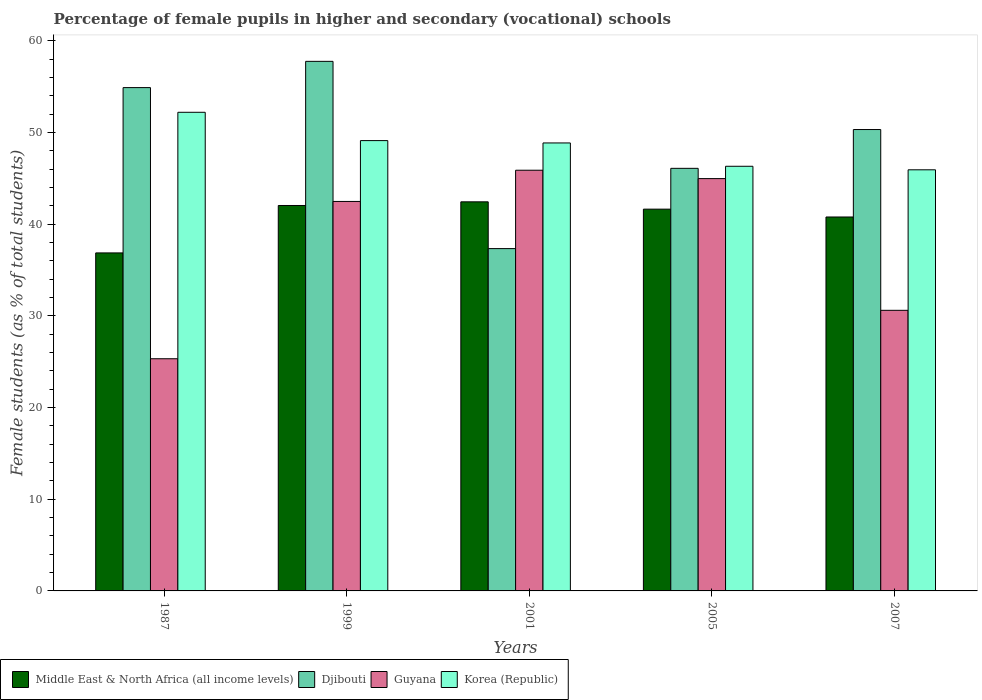How many different coloured bars are there?
Your answer should be very brief. 4. How many groups of bars are there?
Give a very brief answer. 5. How many bars are there on the 3rd tick from the left?
Your response must be concise. 4. How many bars are there on the 3rd tick from the right?
Offer a very short reply. 4. What is the percentage of female pupils in higher and secondary schools in Guyana in 1999?
Your answer should be compact. 42.49. Across all years, what is the maximum percentage of female pupils in higher and secondary schools in Middle East & North Africa (all income levels)?
Your answer should be compact. 42.45. Across all years, what is the minimum percentage of female pupils in higher and secondary schools in Djibouti?
Give a very brief answer. 37.34. In which year was the percentage of female pupils in higher and secondary schools in Middle East & North Africa (all income levels) maximum?
Provide a succinct answer. 2001. What is the total percentage of female pupils in higher and secondary schools in Middle East & North Africa (all income levels) in the graph?
Give a very brief answer. 203.8. What is the difference between the percentage of female pupils in higher and secondary schools in Djibouti in 2001 and that in 2007?
Offer a terse response. -12.99. What is the difference between the percentage of female pupils in higher and secondary schools in Djibouti in 2007 and the percentage of female pupils in higher and secondary schools in Guyana in 2001?
Keep it short and to the point. 4.44. What is the average percentage of female pupils in higher and secondary schools in Korea (Republic) per year?
Ensure brevity in your answer.  48.49. In the year 2007, what is the difference between the percentage of female pupils in higher and secondary schools in Korea (Republic) and percentage of female pupils in higher and secondary schools in Middle East & North Africa (all income levels)?
Provide a short and direct response. 5.15. What is the ratio of the percentage of female pupils in higher and secondary schools in Djibouti in 1999 to that in 2001?
Give a very brief answer. 1.55. Is the percentage of female pupils in higher and secondary schools in Guyana in 1999 less than that in 2007?
Provide a succinct answer. No. Is the difference between the percentage of female pupils in higher and secondary schools in Korea (Republic) in 1987 and 2005 greater than the difference between the percentage of female pupils in higher and secondary schools in Middle East & North Africa (all income levels) in 1987 and 2005?
Make the answer very short. Yes. What is the difference between the highest and the second highest percentage of female pupils in higher and secondary schools in Korea (Republic)?
Your answer should be very brief. 3.09. What is the difference between the highest and the lowest percentage of female pupils in higher and secondary schools in Middle East & North Africa (all income levels)?
Your answer should be compact. 5.57. In how many years, is the percentage of female pupils in higher and secondary schools in Middle East & North Africa (all income levels) greater than the average percentage of female pupils in higher and secondary schools in Middle East & North Africa (all income levels) taken over all years?
Ensure brevity in your answer.  4. What does the 1st bar from the left in 2001 represents?
Ensure brevity in your answer.  Middle East & North Africa (all income levels). What does the 2nd bar from the right in 2001 represents?
Make the answer very short. Guyana. Is it the case that in every year, the sum of the percentage of female pupils in higher and secondary schools in Guyana and percentage of female pupils in higher and secondary schools in Djibouti is greater than the percentage of female pupils in higher and secondary schools in Korea (Republic)?
Offer a very short reply. Yes. Are all the bars in the graph horizontal?
Keep it short and to the point. No. How many years are there in the graph?
Offer a very short reply. 5. Does the graph contain grids?
Give a very brief answer. No. How are the legend labels stacked?
Make the answer very short. Horizontal. What is the title of the graph?
Offer a very short reply. Percentage of female pupils in higher and secondary (vocational) schools. What is the label or title of the X-axis?
Offer a terse response. Years. What is the label or title of the Y-axis?
Offer a terse response. Female students (as % of total students). What is the Female students (as % of total students) of Middle East & North Africa (all income levels) in 1987?
Provide a succinct answer. 36.87. What is the Female students (as % of total students) in Djibouti in 1987?
Offer a very short reply. 54.91. What is the Female students (as % of total students) of Guyana in 1987?
Offer a very short reply. 25.33. What is the Female students (as % of total students) of Korea (Republic) in 1987?
Your answer should be very brief. 52.21. What is the Female students (as % of total students) of Middle East & North Africa (all income levels) in 1999?
Your response must be concise. 42.05. What is the Female students (as % of total students) in Djibouti in 1999?
Your response must be concise. 57.77. What is the Female students (as % of total students) in Guyana in 1999?
Ensure brevity in your answer.  42.49. What is the Female students (as % of total students) of Korea (Republic) in 1999?
Keep it short and to the point. 49.13. What is the Female students (as % of total students) of Middle East & North Africa (all income levels) in 2001?
Make the answer very short. 42.45. What is the Female students (as % of total students) of Djibouti in 2001?
Your answer should be compact. 37.34. What is the Female students (as % of total students) in Guyana in 2001?
Offer a very short reply. 45.89. What is the Female students (as % of total students) of Korea (Republic) in 2001?
Offer a very short reply. 48.87. What is the Female students (as % of total students) in Middle East & North Africa (all income levels) in 2005?
Offer a very short reply. 41.65. What is the Female students (as % of total students) in Djibouti in 2005?
Provide a succinct answer. 46.1. What is the Female students (as % of total students) in Guyana in 2005?
Offer a terse response. 44.98. What is the Female students (as % of total students) in Korea (Republic) in 2005?
Your answer should be compact. 46.33. What is the Female students (as % of total students) in Middle East & North Africa (all income levels) in 2007?
Your response must be concise. 40.79. What is the Female students (as % of total students) in Djibouti in 2007?
Your answer should be compact. 50.33. What is the Female students (as % of total students) of Guyana in 2007?
Provide a short and direct response. 30.61. What is the Female students (as % of total students) in Korea (Republic) in 2007?
Your answer should be very brief. 45.94. Across all years, what is the maximum Female students (as % of total students) in Middle East & North Africa (all income levels)?
Offer a terse response. 42.45. Across all years, what is the maximum Female students (as % of total students) of Djibouti?
Keep it short and to the point. 57.77. Across all years, what is the maximum Female students (as % of total students) in Guyana?
Offer a very short reply. 45.89. Across all years, what is the maximum Female students (as % of total students) of Korea (Republic)?
Provide a short and direct response. 52.21. Across all years, what is the minimum Female students (as % of total students) of Middle East & North Africa (all income levels)?
Your response must be concise. 36.87. Across all years, what is the minimum Female students (as % of total students) of Djibouti?
Offer a terse response. 37.34. Across all years, what is the minimum Female students (as % of total students) of Guyana?
Provide a short and direct response. 25.33. Across all years, what is the minimum Female students (as % of total students) in Korea (Republic)?
Offer a terse response. 45.94. What is the total Female students (as % of total students) of Middle East & North Africa (all income levels) in the graph?
Offer a terse response. 203.8. What is the total Female students (as % of total students) of Djibouti in the graph?
Give a very brief answer. 246.45. What is the total Female students (as % of total students) in Guyana in the graph?
Keep it short and to the point. 189.3. What is the total Female students (as % of total students) of Korea (Republic) in the graph?
Provide a succinct answer. 242.47. What is the difference between the Female students (as % of total students) of Middle East & North Africa (all income levels) in 1987 and that in 1999?
Keep it short and to the point. -5.17. What is the difference between the Female students (as % of total students) of Djibouti in 1987 and that in 1999?
Ensure brevity in your answer.  -2.86. What is the difference between the Female students (as % of total students) in Guyana in 1987 and that in 1999?
Make the answer very short. -17.16. What is the difference between the Female students (as % of total students) of Korea (Republic) in 1987 and that in 1999?
Make the answer very short. 3.09. What is the difference between the Female students (as % of total students) of Middle East & North Africa (all income levels) in 1987 and that in 2001?
Give a very brief answer. -5.57. What is the difference between the Female students (as % of total students) in Djibouti in 1987 and that in 2001?
Ensure brevity in your answer.  17.56. What is the difference between the Female students (as % of total students) in Guyana in 1987 and that in 2001?
Make the answer very short. -20.57. What is the difference between the Female students (as % of total students) of Korea (Republic) in 1987 and that in 2001?
Give a very brief answer. 3.34. What is the difference between the Female students (as % of total students) in Middle East & North Africa (all income levels) in 1987 and that in 2005?
Offer a very short reply. -4.77. What is the difference between the Female students (as % of total students) of Djibouti in 1987 and that in 2005?
Your response must be concise. 8.81. What is the difference between the Female students (as % of total students) in Guyana in 1987 and that in 2005?
Keep it short and to the point. -19.65. What is the difference between the Female students (as % of total students) in Korea (Republic) in 1987 and that in 2005?
Offer a terse response. 5.89. What is the difference between the Female students (as % of total students) in Middle East & North Africa (all income levels) in 1987 and that in 2007?
Give a very brief answer. -3.92. What is the difference between the Female students (as % of total students) in Djibouti in 1987 and that in 2007?
Offer a very short reply. 4.57. What is the difference between the Female students (as % of total students) of Guyana in 1987 and that in 2007?
Give a very brief answer. -5.28. What is the difference between the Female students (as % of total students) in Korea (Republic) in 1987 and that in 2007?
Ensure brevity in your answer.  6.28. What is the difference between the Female students (as % of total students) in Middle East & North Africa (all income levels) in 1999 and that in 2001?
Provide a succinct answer. -0.4. What is the difference between the Female students (as % of total students) of Djibouti in 1999 and that in 2001?
Your answer should be very brief. 20.43. What is the difference between the Female students (as % of total students) in Guyana in 1999 and that in 2001?
Your answer should be very brief. -3.41. What is the difference between the Female students (as % of total students) in Korea (Republic) in 1999 and that in 2001?
Make the answer very short. 0.25. What is the difference between the Female students (as % of total students) of Middle East & North Africa (all income levels) in 1999 and that in 2005?
Provide a short and direct response. 0.4. What is the difference between the Female students (as % of total students) of Djibouti in 1999 and that in 2005?
Offer a terse response. 11.67. What is the difference between the Female students (as % of total students) in Guyana in 1999 and that in 2005?
Make the answer very short. -2.49. What is the difference between the Female students (as % of total students) of Korea (Republic) in 1999 and that in 2005?
Your answer should be very brief. 2.8. What is the difference between the Female students (as % of total students) of Middle East & North Africa (all income levels) in 1999 and that in 2007?
Your response must be concise. 1.25. What is the difference between the Female students (as % of total students) in Djibouti in 1999 and that in 2007?
Your answer should be compact. 7.44. What is the difference between the Female students (as % of total students) of Guyana in 1999 and that in 2007?
Ensure brevity in your answer.  11.88. What is the difference between the Female students (as % of total students) of Korea (Republic) in 1999 and that in 2007?
Offer a very short reply. 3.19. What is the difference between the Female students (as % of total students) in Middle East & North Africa (all income levels) in 2001 and that in 2005?
Your response must be concise. 0.8. What is the difference between the Female students (as % of total students) of Djibouti in 2001 and that in 2005?
Give a very brief answer. -8.76. What is the difference between the Female students (as % of total students) in Guyana in 2001 and that in 2005?
Give a very brief answer. 0.91. What is the difference between the Female students (as % of total students) in Korea (Republic) in 2001 and that in 2005?
Your answer should be compact. 2.54. What is the difference between the Female students (as % of total students) of Middle East & North Africa (all income levels) in 2001 and that in 2007?
Provide a succinct answer. 1.65. What is the difference between the Female students (as % of total students) of Djibouti in 2001 and that in 2007?
Provide a succinct answer. -12.99. What is the difference between the Female students (as % of total students) in Guyana in 2001 and that in 2007?
Your answer should be compact. 15.28. What is the difference between the Female students (as % of total students) in Korea (Republic) in 2001 and that in 2007?
Your response must be concise. 2.93. What is the difference between the Female students (as % of total students) of Middle East & North Africa (all income levels) in 2005 and that in 2007?
Keep it short and to the point. 0.85. What is the difference between the Female students (as % of total students) in Djibouti in 2005 and that in 2007?
Offer a terse response. -4.23. What is the difference between the Female students (as % of total students) in Guyana in 2005 and that in 2007?
Your answer should be compact. 14.37. What is the difference between the Female students (as % of total students) in Korea (Republic) in 2005 and that in 2007?
Provide a short and direct response. 0.39. What is the difference between the Female students (as % of total students) of Middle East & North Africa (all income levels) in 1987 and the Female students (as % of total students) of Djibouti in 1999?
Make the answer very short. -20.9. What is the difference between the Female students (as % of total students) in Middle East & North Africa (all income levels) in 1987 and the Female students (as % of total students) in Guyana in 1999?
Provide a short and direct response. -5.62. What is the difference between the Female students (as % of total students) in Middle East & North Africa (all income levels) in 1987 and the Female students (as % of total students) in Korea (Republic) in 1999?
Your answer should be very brief. -12.25. What is the difference between the Female students (as % of total students) in Djibouti in 1987 and the Female students (as % of total students) in Guyana in 1999?
Your answer should be compact. 12.42. What is the difference between the Female students (as % of total students) of Djibouti in 1987 and the Female students (as % of total students) of Korea (Republic) in 1999?
Offer a terse response. 5.78. What is the difference between the Female students (as % of total students) of Guyana in 1987 and the Female students (as % of total students) of Korea (Republic) in 1999?
Make the answer very short. -23.8. What is the difference between the Female students (as % of total students) of Middle East & North Africa (all income levels) in 1987 and the Female students (as % of total students) of Djibouti in 2001?
Give a very brief answer. -0.47. What is the difference between the Female students (as % of total students) in Middle East & North Africa (all income levels) in 1987 and the Female students (as % of total students) in Guyana in 2001?
Your answer should be compact. -9.02. What is the difference between the Female students (as % of total students) in Middle East & North Africa (all income levels) in 1987 and the Female students (as % of total students) in Korea (Republic) in 2001?
Your answer should be compact. -12. What is the difference between the Female students (as % of total students) in Djibouti in 1987 and the Female students (as % of total students) in Guyana in 2001?
Your response must be concise. 9.01. What is the difference between the Female students (as % of total students) of Djibouti in 1987 and the Female students (as % of total students) of Korea (Republic) in 2001?
Your answer should be very brief. 6.04. What is the difference between the Female students (as % of total students) of Guyana in 1987 and the Female students (as % of total students) of Korea (Republic) in 2001?
Keep it short and to the point. -23.54. What is the difference between the Female students (as % of total students) of Middle East & North Africa (all income levels) in 1987 and the Female students (as % of total students) of Djibouti in 2005?
Your answer should be very brief. -9.23. What is the difference between the Female students (as % of total students) in Middle East & North Africa (all income levels) in 1987 and the Female students (as % of total students) in Guyana in 2005?
Provide a short and direct response. -8.11. What is the difference between the Female students (as % of total students) in Middle East & North Africa (all income levels) in 1987 and the Female students (as % of total students) in Korea (Republic) in 2005?
Offer a terse response. -9.45. What is the difference between the Female students (as % of total students) of Djibouti in 1987 and the Female students (as % of total students) of Guyana in 2005?
Make the answer very short. 9.93. What is the difference between the Female students (as % of total students) in Djibouti in 1987 and the Female students (as % of total students) in Korea (Republic) in 2005?
Ensure brevity in your answer.  8.58. What is the difference between the Female students (as % of total students) of Guyana in 1987 and the Female students (as % of total students) of Korea (Republic) in 2005?
Offer a terse response. -21. What is the difference between the Female students (as % of total students) of Middle East & North Africa (all income levels) in 1987 and the Female students (as % of total students) of Djibouti in 2007?
Keep it short and to the point. -13.46. What is the difference between the Female students (as % of total students) of Middle East & North Africa (all income levels) in 1987 and the Female students (as % of total students) of Guyana in 2007?
Offer a terse response. 6.26. What is the difference between the Female students (as % of total students) in Middle East & North Africa (all income levels) in 1987 and the Female students (as % of total students) in Korea (Republic) in 2007?
Provide a succinct answer. -9.07. What is the difference between the Female students (as % of total students) in Djibouti in 1987 and the Female students (as % of total students) in Guyana in 2007?
Make the answer very short. 24.3. What is the difference between the Female students (as % of total students) of Djibouti in 1987 and the Female students (as % of total students) of Korea (Republic) in 2007?
Offer a very short reply. 8.97. What is the difference between the Female students (as % of total students) of Guyana in 1987 and the Female students (as % of total students) of Korea (Republic) in 2007?
Offer a very short reply. -20.61. What is the difference between the Female students (as % of total students) of Middle East & North Africa (all income levels) in 1999 and the Female students (as % of total students) of Djibouti in 2001?
Ensure brevity in your answer.  4.7. What is the difference between the Female students (as % of total students) in Middle East & North Africa (all income levels) in 1999 and the Female students (as % of total students) in Guyana in 2001?
Make the answer very short. -3.85. What is the difference between the Female students (as % of total students) in Middle East & North Africa (all income levels) in 1999 and the Female students (as % of total students) in Korea (Republic) in 2001?
Give a very brief answer. -6.82. What is the difference between the Female students (as % of total students) of Djibouti in 1999 and the Female students (as % of total students) of Guyana in 2001?
Your answer should be compact. 11.88. What is the difference between the Female students (as % of total students) of Djibouti in 1999 and the Female students (as % of total students) of Korea (Republic) in 2001?
Your answer should be compact. 8.9. What is the difference between the Female students (as % of total students) in Guyana in 1999 and the Female students (as % of total students) in Korea (Republic) in 2001?
Give a very brief answer. -6.38. What is the difference between the Female students (as % of total students) in Middle East & North Africa (all income levels) in 1999 and the Female students (as % of total students) in Djibouti in 2005?
Your response must be concise. -4.05. What is the difference between the Female students (as % of total students) in Middle East & North Africa (all income levels) in 1999 and the Female students (as % of total students) in Guyana in 2005?
Keep it short and to the point. -2.93. What is the difference between the Female students (as % of total students) in Middle East & North Africa (all income levels) in 1999 and the Female students (as % of total students) in Korea (Republic) in 2005?
Your response must be concise. -4.28. What is the difference between the Female students (as % of total students) in Djibouti in 1999 and the Female students (as % of total students) in Guyana in 2005?
Your response must be concise. 12.79. What is the difference between the Female students (as % of total students) of Djibouti in 1999 and the Female students (as % of total students) of Korea (Republic) in 2005?
Ensure brevity in your answer.  11.44. What is the difference between the Female students (as % of total students) of Guyana in 1999 and the Female students (as % of total students) of Korea (Republic) in 2005?
Keep it short and to the point. -3.84. What is the difference between the Female students (as % of total students) in Middle East & North Africa (all income levels) in 1999 and the Female students (as % of total students) in Djibouti in 2007?
Your answer should be compact. -8.29. What is the difference between the Female students (as % of total students) of Middle East & North Africa (all income levels) in 1999 and the Female students (as % of total students) of Guyana in 2007?
Give a very brief answer. 11.44. What is the difference between the Female students (as % of total students) of Middle East & North Africa (all income levels) in 1999 and the Female students (as % of total students) of Korea (Republic) in 2007?
Give a very brief answer. -3.89. What is the difference between the Female students (as % of total students) in Djibouti in 1999 and the Female students (as % of total students) in Guyana in 2007?
Offer a very short reply. 27.16. What is the difference between the Female students (as % of total students) of Djibouti in 1999 and the Female students (as % of total students) of Korea (Republic) in 2007?
Your answer should be compact. 11.83. What is the difference between the Female students (as % of total students) in Guyana in 1999 and the Female students (as % of total students) in Korea (Republic) in 2007?
Give a very brief answer. -3.45. What is the difference between the Female students (as % of total students) of Middle East & North Africa (all income levels) in 2001 and the Female students (as % of total students) of Djibouti in 2005?
Your answer should be very brief. -3.66. What is the difference between the Female students (as % of total students) of Middle East & North Africa (all income levels) in 2001 and the Female students (as % of total students) of Guyana in 2005?
Keep it short and to the point. -2.53. What is the difference between the Female students (as % of total students) of Middle East & North Africa (all income levels) in 2001 and the Female students (as % of total students) of Korea (Republic) in 2005?
Keep it short and to the point. -3.88. What is the difference between the Female students (as % of total students) of Djibouti in 2001 and the Female students (as % of total students) of Guyana in 2005?
Ensure brevity in your answer.  -7.64. What is the difference between the Female students (as % of total students) in Djibouti in 2001 and the Female students (as % of total students) in Korea (Republic) in 2005?
Your answer should be compact. -8.98. What is the difference between the Female students (as % of total students) in Guyana in 2001 and the Female students (as % of total students) in Korea (Republic) in 2005?
Your answer should be very brief. -0.43. What is the difference between the Female students (as % of total students) in Middle East & North Africa (all income levels) in 2001 and the Female students (as % of total students) in Djibouti in 2007?
Provide a succinct answer. -7.89. What is the difference between the Female students (as % of total students) of Middle East & North Africa (all income levels) in 2001 and the Female students (as % of total students) of Guyana in 2007?
Provide a succinct answer. 11.83. What is the difference between the Female students (as % of total students) of Middle East & North Africa (all income levels) in 2001 and the Female students (as % of total students) of Korea (Republic) in 2007?
Offer a terse response. -3.49. What is the difference between the Female students (as % of total students) in Djibouti in 2001 and the Female students (as % of total students) in Guyana in 2007?
Provide a short and direct response. 6.73. What is the difference between the Female students (as % of total students) of Djibouti in 2001 and the Female students (as % of total students) of Korea (Republic) in 2007?
Provide a short and direct response. -8.6. What is the difference between the Female students (as % of total students) of Guyana in 2001 and the Female students (as % of total students) of Korea (Republic) in 2007?
Your answer should be very brief. -0.05. What is the difference between the Female students (as % of total students) in Middle East & North Africa (all income levels) in 2005 and the Female students (as % of total students) in Djibouti in 2007?
Make the answer very short. -8.68. What is the difference between the Female students (as % of total students) in Middle East & North Africa (all income levels) in 2005 and the Female students (as % of total students) in Guyana in 2007?
Provide a short and direct response. 11.04. What is the difference between the Female students (as % of total students) in Middle East & North Africa (all income levels) in 2005 and the Female students (as % of total students) in Korea (Republic) in 2007?
Your answer should be compact. -4.29. What is the difference between the Female students (as % of total students) in Djibouti in 2005 and the Female students (as % of total students) in Guyana in 2007?
Ensure brevity in your answer.  15.49. What is the difference between the Female students (as % of total students) of Djibouti in 2005 and the Female students (as % of total students) of Korea (Republic) in 2007?
Make the answer very short. 0.16. What is the difference between the Female students (as % of total students) in Guyana in 2005 and the Female students (as % of total students) in Korea (Republic) in 2007?
Make the answer very short. -0.96. What is the average Female students (as % of total students) in Middle East & North Africa (all income levels) per year?
Keep it short and to the point. 40.76. What is the average Female students (as % of total students) of Djibouti per year?
Provide a short and direct response. 49.29. What is the average Female students (as % of total students) in Guyana per year?
Provide a succinct answer. 37.86. What is the average Female students (as % of total students) in Korea (Republic) per year?
Provide a short and direct response. 48.49. In the year 1987, what is the difference between the Female students (as % of total students) in Middle East & North Africa (all income levels) and Female students (as % of total students) in Djibouti?
Keep it short and to the point. -18.03. In the year 1987, what is the difference between the Female students (as % of total students) in Middle East & North Africa (all income levels) and Female students (as % of total students) in Guyana?
Give a very brief answer. 11.55. In the year 1987, what is the difference between the Female students (as % of total students) of Middle East & North Africa (all income levels) and Female students (as % of total students) of Korea (Republic)?
Your answer should be very brief. -15.34. In the year 1987, what is the difference between the Female students (as % of total students) of Djibouti and Female students (as % of total students) of Guyana?
Your response must be concise. 29.58. In the year 1987, what is the difference between the Female students (as % of total students) of Djibouti and Female students (as % of total students) of Korea (Republic)?
Ensure brevity in your answer.  2.69. In the year 1987, what is the difference between the Female students (as % of total students) in Guyana and Female students (as % of total students) in Korea (Republic)?
Make the answer very short. -26.89. In the year 1999, what is the difference between the Female students (as % of total students) in Middle East & North Africa (all income levels) and Female students (as % of total students) in Djibouti?
Offer a very short reply. -15.72. In the year 1999, what is the difference between the Female students (as % of total students) of Middle East & North Africa (all income levels) and Female students (as % of total students) of Guyana?
Offer a very short reply. -0.44. In the year 1999, what is the difference between the Female students (as % of total students) of Middle East & North Africa (all income levels) and Female students (as % of total students) of Korea (Republic)?
Offer a terse response. -7.08. In the year 1999, what is the difference between the Female students (as % of total students) in Djibouti and Female students (as % of total students) in Guyana?
Make the answer very short. 15.28. In the year 1999, what is the difference between the Female students (as % of total students) of Djibouti and Female students (as % of total students) of Korea (Republic)?
Your answer should be very brief. 8.65. In the year 1999, what is the difference between the Female students (as % of total students) in Guyana and Female students (as % of total students) in Korea (Republic)?
Offer a very short reply. -6.64. In the year 2001, what is the difference between the Female students (as % of total students) in Middle East & North Africa (all income levels) and Female students (as % of total students) in Djibouti?
Make the answer very short. 5.1. In the year 2001, what is the difference between the Female students (as % of total students) in Middle East & North Africa (all income levels) and Female students (as % of total students) in Guyana?
Provide a succinct answer. -3.45. In the year 2001, what is the difference between the Female students (as % of total students) of Middle East & North Africa (all income levels) and Female students (as % of total students) of Korea (Republic)?
Offer a very short reply. -6.42. In the year 2001, what is the difference between the Female students (as % of total students) of Djibouti and Female students (as % of total students) of Guyana?
Keep it short and to the point. -8.55. In the year 2001, what is the difference between the Female students (as % of total students) of Djibouti and Female students (as % of total students) of Korea (Republic)?
Make the answer very short. -11.53. In the year 2001, what is the difference between the Female students (as % of total students) in Guyana and Female students (as % of total students) in Korea (Republic)?
Your answer should be very brief. -2.98. In the year 2005, what is the difference between the Female students (as % of total students) in Middle East & North Africa (all income levels) and Female students (as % of total students) in Djibouti?
Offer a very short reply. -4.45. In the year 2005, what is the difference between the Female students (as % of total students) of Middle East & North Africa (all income levels) and Female students (as % of total students) of Guyana?
Make the answer very short. -3.33. In the year 2005, what is the difference between the Female students (as % of total students) in Middle East & North Africa (all income levels) and Female students (as % of total students) in Korea (Republic)?
Ensure brevity in your answer.  -4.68. In the year 2005, what is the difference between the Female students (as % of total students) of Djibouti and Female students (as % of total students) of Guyana?
Make the answer very short. 1.12. In the year 2005, what is the difference between the Female students (as % of total students) of Djibouti and Female students (as % of total students) of Korea (Republic)?
Make the answer very short. -0.23. In the year 2005, what is the difference between the Female students (as % of total students) in Guyana and Female students (as % of total students) in Korea (Republic)?
Ensure brevity in your answer.  -1.35. In the year 2007, what is the difference between the Female students (as % of total students) of Middle East & North Africa (all income levels) and Female students (as % of total students) of Djibouti?
Your answer should be compact. -9.54. In the year 2007, what is the difference between the Female students (as % of total students) in Middle East & North Africa (all income levels) and Female students (as % of total students) in Guyana?
Your response must be concise. 10.18. In the year 2007, what is the difference between the Female students (as % of total students) in Middle East & North Africa (all income levels) and Female students (as % of total students) in Korea (Republic)?
Make the answer very short. -5.15. In the year 2007, what is the difference between the Female students (as % of total students) of Djibouti and Female students (as % of total students) of Guyana?
Offer a very short reply. 19.72. In the year 2007, what is the difference between the Female students (as % of total students) in Djibouti and Female students (as % of total students) in Korea (Republic)?
Offer a very short reply. 4.39. In the year 2007, what is the difference between the Female students (as % of total students) in Guyana and Female students (as % of total students) in Korea (Republic)?
Your answer should be very brief. -15.33. What is the ratio of the Female students (as % of total students) of Middle East & North Africa (all income levels) in 1987 to that in 1999?
Provide a short and direct response. 0.88. What is the ratio of the Female students (as % of total students) of Djibouti in 1987 to that in 1999?
Make the answer very short. 0.95. What is the ratio of the Female students (as % of total students) of Guyana in 1987 to that in 1999?
Your answer should be very brief. 0.6. What is the ratio of the Female students (as % of total students) in Korea (Republic) in 1987 to that in 1999?
Ensure brevity in your answer.  1.06. What is the ratio of the Female students (as % of total students) in Middle East & North Africa (all income levels) in 1987 to that in 2001?
Provide a succinct answer. 0.87. What is the ratio of the Female students (as % of total students) in Djibouti in 1987 to that in 2001?
Offer a terse response. 1.47. What is the ratio of the Female students (as % of total students) of Guyana in 1987 to that in 2001?
Your answer should be compact. 0.55. What is the ratio of the Female students (as % of total students) in Korea (Republic) in 1987 to that in 2001?
Make the answer very short. 1.07. What is the ratio of the Female students (as % of total students) of Middle East & North Africa (all income levels) in 1987 to that in 2005?
Your answer should be compact. 0.89. What is the ratio of the Female students (as % of total students) in Djibouti in 1987 to that in 2005?
Ensure brevity in your answer.  1.19. What is the ratio of the Female students (as % of total students) of Guyana in 1987 to that in 2005?
Make the answer very short. 0.56. What is the ratio of the Female students (as % of total students) in Korea (Republic) in 1987 to that in 2005?
Ensure brevity in your answer.  1.13. What is the ratio of the Female students (as % of total students) of Middle East & North Africa (all income levels) in 1987 to that in 2007?
Your response must be concise. 0.9. What is the ratio of the Female students (as % of total students) of Guyana in 1987 to that in 2007?
Give a very brief answer. 0.83. What is the ratio of the Female students (as % of total students) of Korea (Republic) in 1987 to that in 2007?
Keep it short and to the point. 1.14. What is the ratio of the Female students (as % of total students) of Middle East & North Africa (all income levels) in 1999 to that in 2001?
Ensure brevity in your answer.  0.99. What is the ratio of the Female students (as % of total students) of Djibouti in 1999 to that in 2001?
Ensure brevity in your answer.  1.55. What is the ratio of the Female students (as % of total students) of Guyana in 1999 to that in 2001?
Your response must be concise. 0.93. What is the ratio of the Female students (as % of total students) of Middle East & North Africa (all income levels) in 1999 to that in 2005?
Keep it short and to the point. 1.01. What is the ratio of the Female students (as % of total students) of Djibouti in 1999 to that in 2005?
Make the answer very short. 1.25. What is the ratio of the Female students (as % of total students) of Guyana in 1999 to that in 2005?
Your answer should be very brief. 0.94. What is the ratio of the Female students (as % of total students) in Korea (Republic) in 1999 to that in 2005?
Your answer should be very brief. 1.06. What is the ratio of the Female students (as % of total students) of Middle East & North Africa (all income levels) in 1999 to that in 2007?
Offer a very short reply. 1.03. What is the ratio of the Female students (as % of total students) of Djibouti in 1999 to that in 2007?
Your response must be concise. 1.15. What is the ratio of the Female students (as % of total students) in Guyana in 1999 to that in 2007?
Give a very brief answer. 1.39. What is the ratio of the Female students (as % of total students) of Korea (Republic) in 1999 to that in 2007?
Give a very brief answer. 1.07. What is the ratio of the Female students (as % of total students) of Middle East & North Africa (all income levels) in 2001 to that in 2005?
Your response must be concise. 1.02. What is the ratio of the Female students (as % of total students) in Djibouti in 2001 to that in 2005?
Your answer should be very brief. 0.81. What is the ratio of the Female students (as % of total students) of Guyana in 2001 to that in 2005?
Your answer should be compact. 1.02. What is the ratio of the Female students (as % of total students) of Korea (Republic) in 2001 to that in 2005?
Keep it short and to the point. 1.05. What is the ratio of the Female students (as % of total students) in Middle East & North Africa (all income levels) in 2001 to that in 2007?
Provide a succinct answer. 1.04. What is the ratio of the Female students (as % of total students) in Djibouti in 2001 to that in 2007?
Keep it short and to the point. 0.74. What is the ratio of the Female students (as % of total students) of Guyana in 2001 to that in 2007?
Your answer should be very brief. 1.5. What is the ratio of the Female students (as % of total students) in Korea (Republic) in 2001 to that in 2007?
Give a very brief answer. 1.06. What is the ratio of the Female students (as % of total students) of Middle East & North Africa (all income levels) in 2005 to that in 2007?
Make the answer very short. 1.02. What is the ratio of the Female students (as % of total students) of Djibouti in 2005 to that in 2007?
Give a very brief answer. 0.92. What is the ratio of the Female students (as % of total students) of Guyana in 2005 to that in 2007?
Offer a terse response. 1.47. What is the ratio of the Female students (as % of total students) of Korea (Republic) in 2005 to that in 2007?
Provide a short and direct response. 1.01. What is the difference between the highest and the second highest Female students (as % of total students) in Middle East & North Africa (all income levels)?
Your response must be concise. 0.4. What is the difference between the highest and the second highest Female students (as % of total students) of Djibouti?
Ensure brevity in your answer.  2.86. What is the difference between the highest and the second highest Female students (as % of total students) in Guyana?
Provide a short and direct response. 0.91. What is the difference between the highest and the second highest Female students (as % of total students) of Korea (Republic)?
Your answer should be compact. 3.09. What is the difference between the highest and the lowest Female students (as % of total students) of Middle East & North Africa (all income levels)?
Give a very brief answer. 5.57. What is the difference between the highest and the lowest Female students (as % of total students) of Djibouti?
Your answer should be very brief. 20.43. What is the difference between the highest and the lowest Female students (as % of total students) of Guyana?
Offer a very short reply. 20.57. What is the difference between the highest and the lowest Female students (as % of total students) in Korea (Republic)?
Offer a very short reply. 6.28. 